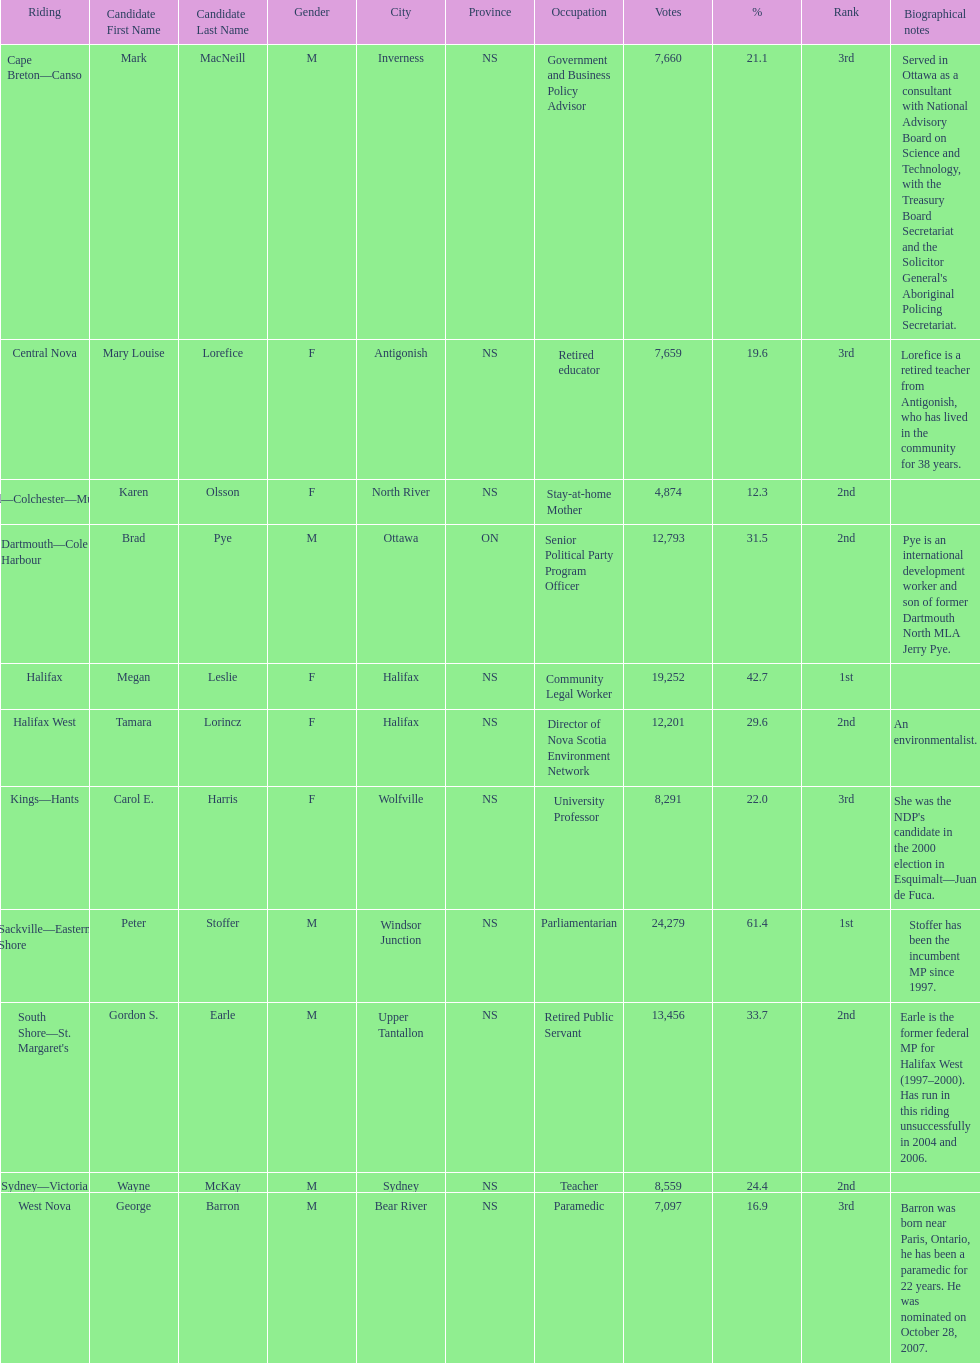How many candidates were from halifax? 2. 